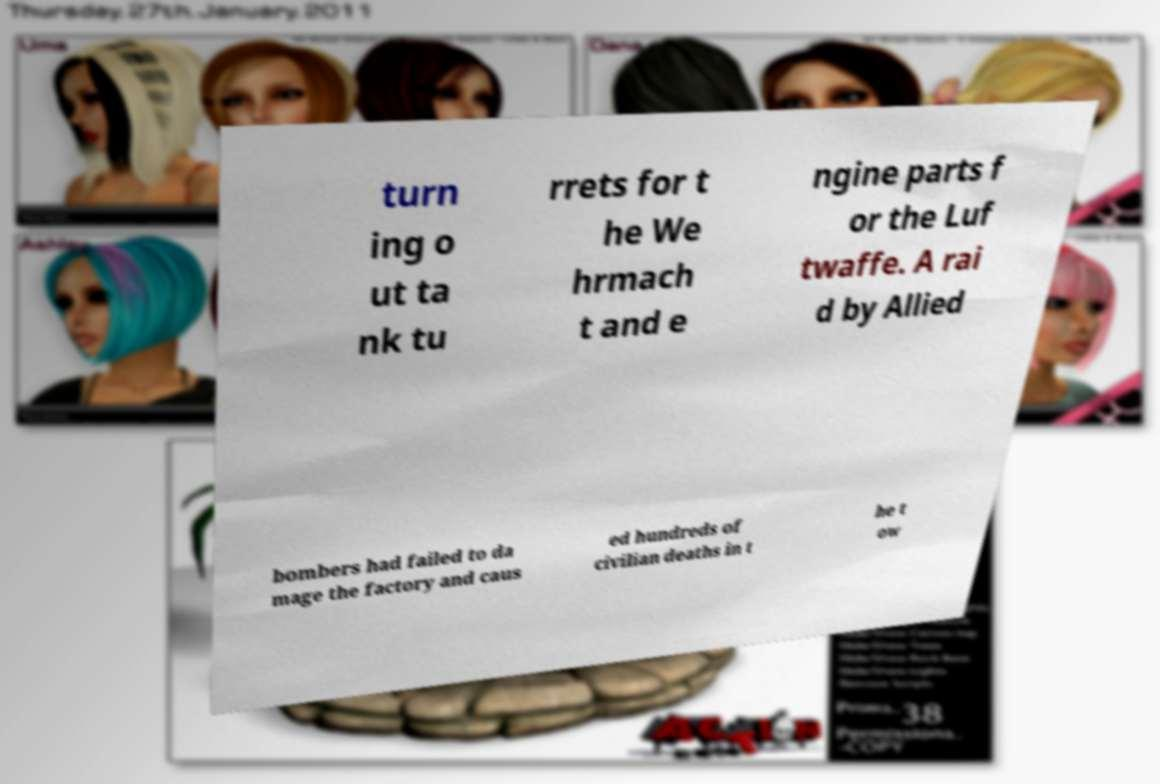Could you assist in decoding the text presented in this image and type it out clearly? turn ing o ut ta nk tu rrets for t he We hrmach t and e ngine parts f or the Luf twaffe. A rai d by Allied bombers had failed to da mage the factory and caus ed hundreds of civilian deaths in t he t ow 